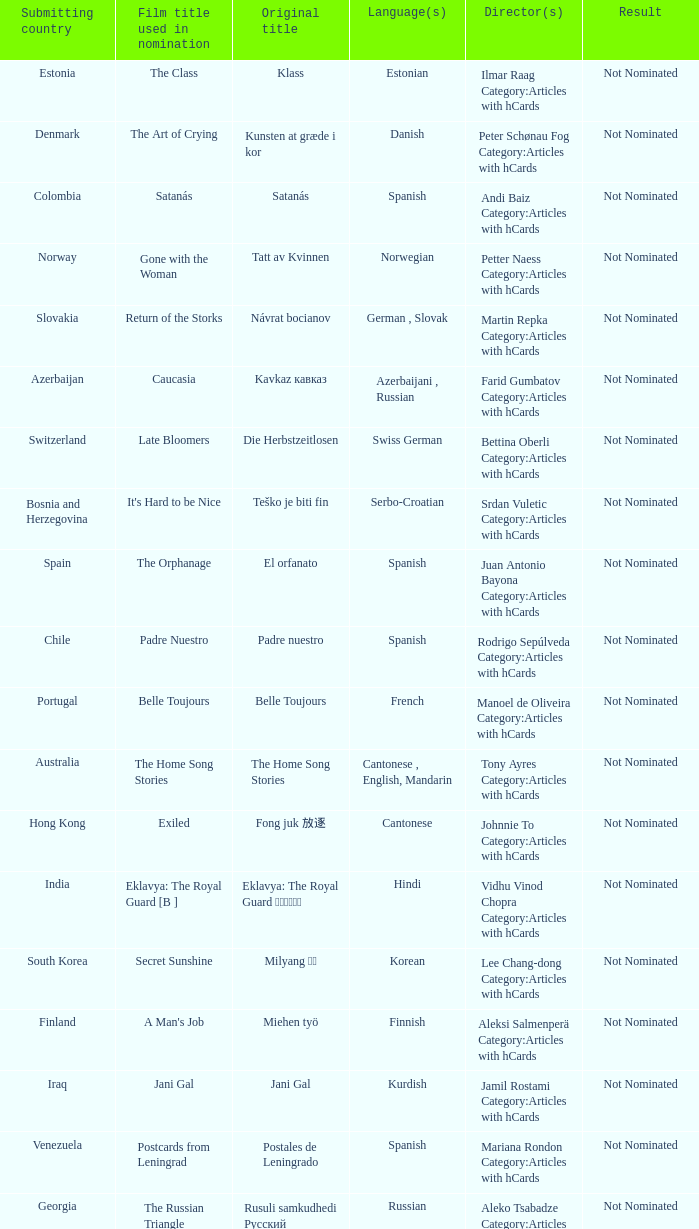What country submitted miehen työ? Finland. 